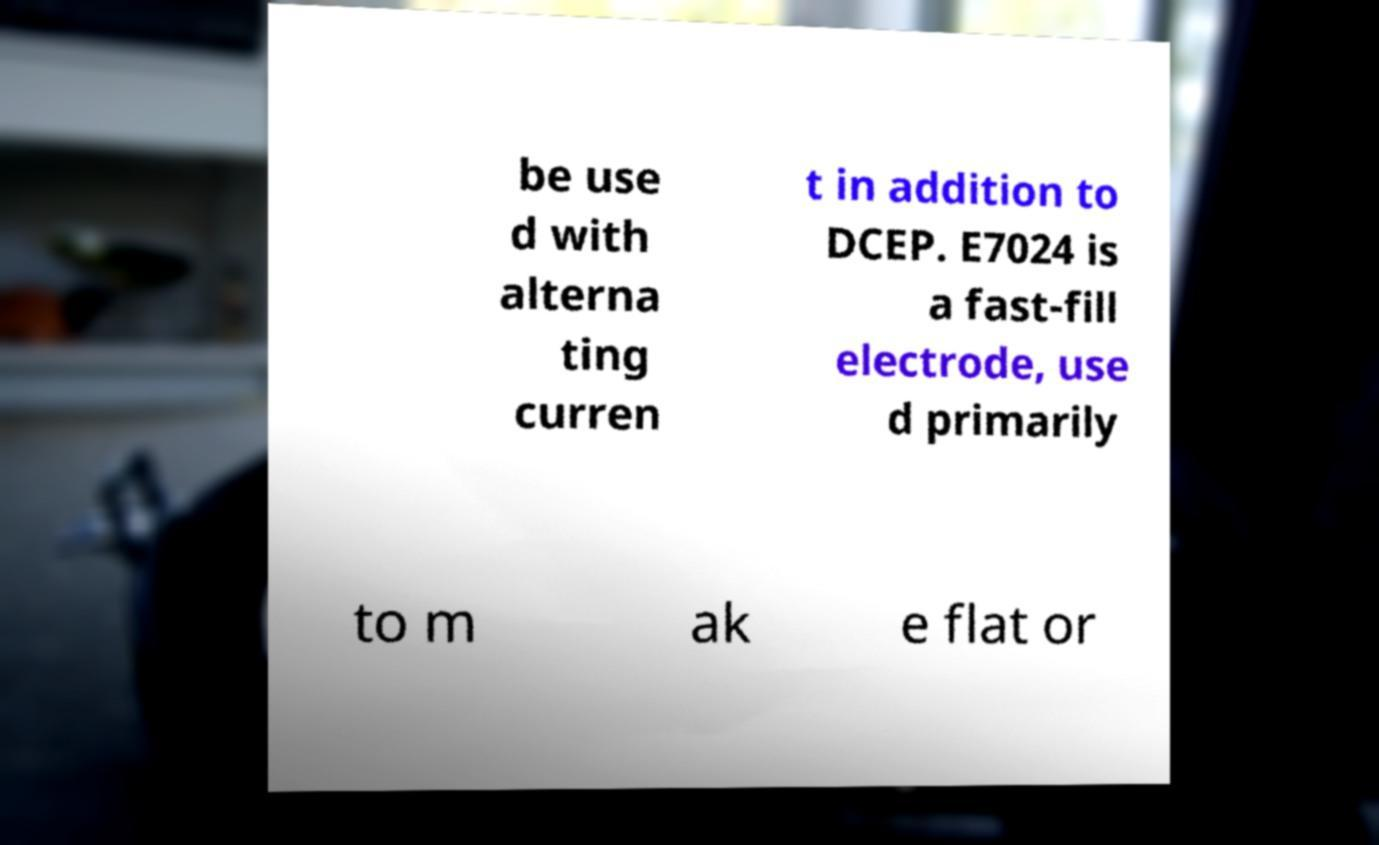What messages or text are displayed in this image? I need them in a readable, typed format. be use d with alterna ting curren t in addition to DCEP. E7024 is a fast-fill electrode, use d primarily to m ak e flat or 